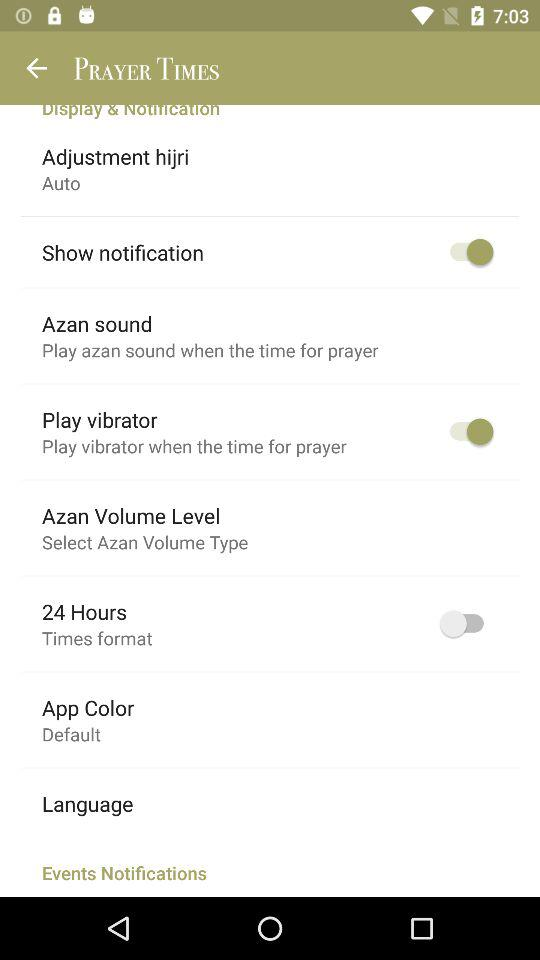What's the setting for the "Adjustment hijri"? The setting for the "Adjustment hijri" is "Auto". 